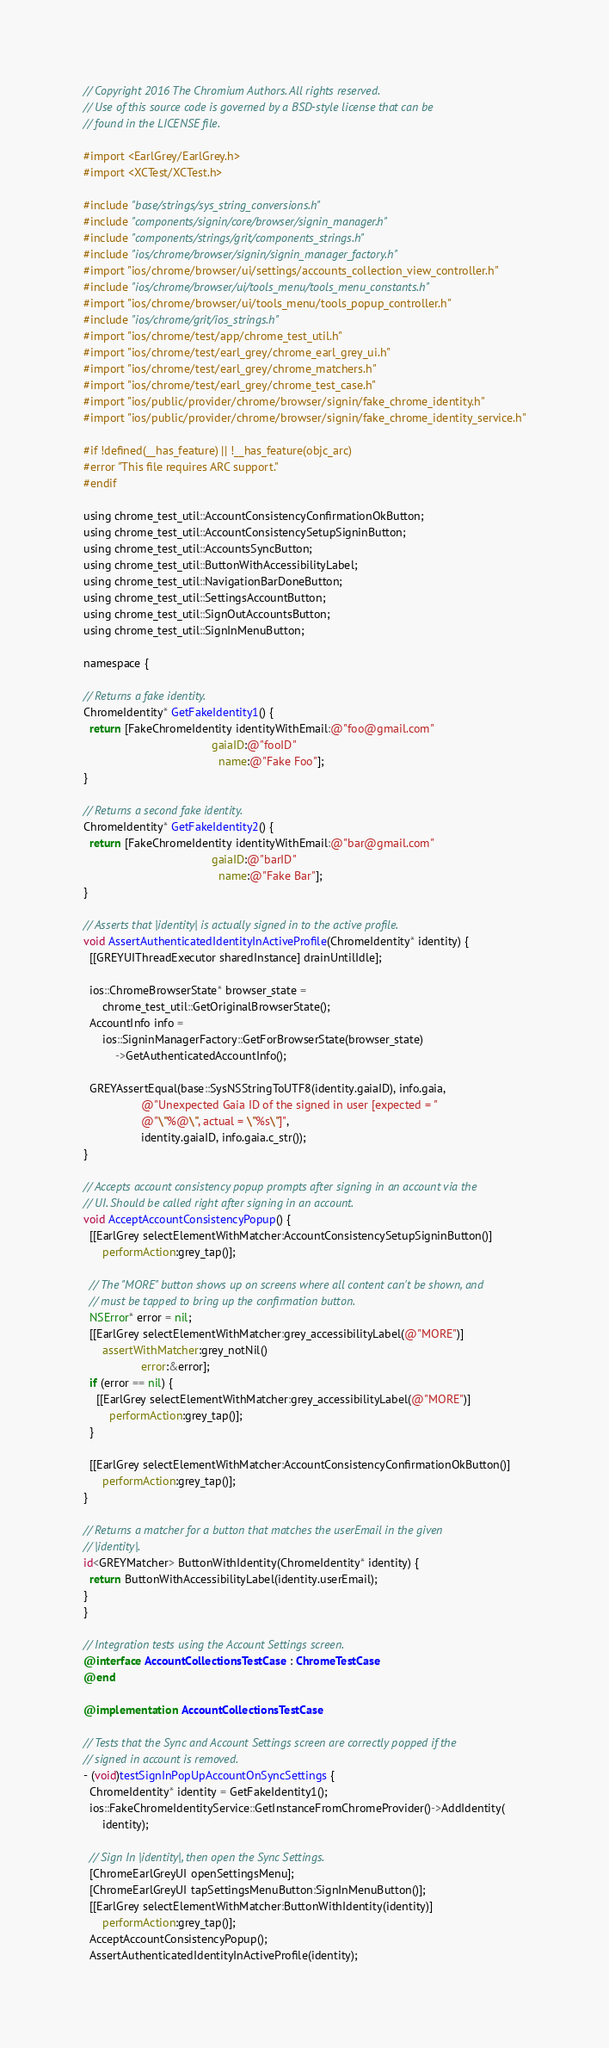Convert code to text. <code><loc_0><loc_0><loc_500><loc_500><_ObjectiveC_>// Copyright 2016 The Chromium Authors. All rights reserved.
// Use of this source code is governed by a BSD-style license that can be
// found in the LICENSE file.

#import <EarlGrey/EarlGrey.h>
#import <XCTest/XCTest.h>

#include "base/strings/sys_string_conversions.h"
#include "components/signin/core/browser/signin_manager.h"
#include "components/strings/grit/components_strings.h"
#include "ios/chrome/browser/signin/signin_manager_factory.h"
#import "ios/chrome/browser/ui/settings/accounts_collection_view_controller.h"
#include "ios/chrome/browser/ui/tools_menu/tools_menu_constants.h"
#import "ios/chrome/browser/ui/tools_menu/tools_popup_controller.h"
#include "ios/chrome/grit/ios_strings.h"
#import "ios/chrome/test/app/chrome_test_util.h"
#import "ios/chrome/test/earl_grey/chrome_earl_grey_ui.h"
#import "ios/chrome/test/earl_grey/chrome_matchers.h"
#import "ios/chrome/test/earl_grey/chrome_test_case.h"
#import "ios/public/provider/chrome/browser/signin/fake_chrome_identity.h"
#import "ios/public/provider/chrome/browser/signin/fake_chrome_identity_service.h"

#if !defined(__has_feature) || !__has_feature(objc_arc)
#error "This file requires ARC support."
#endif

using chrome_test_util::AccountConsistencyConfirmationOkButton;
using chrome_test_util::AccountConsistencySetupSigninButton;
using chrome_test_util::AccountsSyncButton;
using chrome_test_util::ButtonWithAccessibilityLabel;
using chrome_test_util::NavigationBarDoneButton;
using chrome_test_util::SettingsAccountButton;
using chrome_test_util::SignOutAccountsButton;
using chrome_test_util::SignInMenuButton;

namespace {

// Returns a fake identity.
ChromeIdentity* GetFakeIdentity1() {
  return [FakeChromeIdentity identityWithEmail:@"foo@gmail.com"
                                        gaiaID:@"fooID"
                                          name:@"Fake Foo"];
}

// Returns a second fake identity.
ChromeIdentity* GetFakeIdentity2() {
  return [FakeChromeIdentity identityWithEmail:@"bar@gmail.com"
                                        gaiaID:@"barID"
                                          name:@"Fake Bar"];
}

// Asserts that |identity| is actually signed in to the active profile.
void AssertAuthenticatedIdentityInActiveProfile(ChromeIdentity* identity) {
  [[GREYUIThreadExecutor sharedInstance] drainUntilIdle];

  ios::ChromeBrowserState* browser_state =
      chrome_test_util::GetOriginalBrowserState();
  AccountInfo info =
      ios::SigninManagerFactory::GetForBrowserState(browser_state)
          ->GetAuthenticatedAccountInfo();

  GREYAssertEqual(base::SysNSStringToUTF8(identity.gaiaID), info.gaia,
                  @"Unexpected Gaia ID of the signed in user [expected = "
                  @"\"%@\", actual = \"%s\"]",
                  identity.gaiaID, info.gaia.c_str());
}

// Accepts account consistency popup prompts after signing in an account via the
// UI. Should be called right after signing in an account.
void AcceptAccountConsistencyPopup() {
  [[EarlGrey selectElementWithMatcher:AccountConsistencySetupSigninButton()]
      performAction:grey_tap()];

  // The "MORE" button shows up on screens where all content can't be shown, and
  // must be tapped to bring up the confirmation button.
  NSError* error = nil;
  [[EarlGrey selectElementWithMatcher:grey_accessibilityLabel(@"MORE")]
      assertWithMatcher:grey_notNil()
                  error:&error];
  if (error == nil) {
    [[EarlGrey selectElementWithMatcher:grey_accessibilityLabel(@"MORE")]
        performAction:grey_tap()];
  }

  [[EarlGrey selectElementWithMatcher:AccountConsistencyConfirmationOkButton()]
      performAction:grey_tap()];
}

// Returns a matcher for a button that matches the userEmail in the given
// |identity|.
id<GREYMatcher> ButtonWithIdentity(ChromeIdentity* identity) {
  return ButtonWithAccessibilityLabel(identity.userEmail);
}
}

// Integration tests using the Account Settings screen.
@interface AccountCollectionsTestCase : ChromeTestCase
@end

@implementation AccountCollectionsTestCase

// Tests that the Sync and Account Settings screen are correctly popped if the
// signed in account is removed.
- (void)testSignInPopUpAccountOnSyncSettings {
  ChromeIdentity* identity = GetFakeIdentity1();
  ios::FakeChromeIdentityService::GetInstanceFromChromeProvider()->AddIdentity(
      identity);

  // Sign In |identity|, then open the Sync Settings.
  [ChromeEarlGreyUI openSettingsMenu];
  [ChromeEarlGreyUI tapSettingsMenuButton:SignInMenuButton()];
  [[EarlGrey selectElementWithMatcher:ButtonWithIdentity(identity)]
      performAction:grey_tap()];
  AcceptAccountConsistencyPopup();
  AssertAuthenticatedIdentityInActiveProfile(identity);</code> 